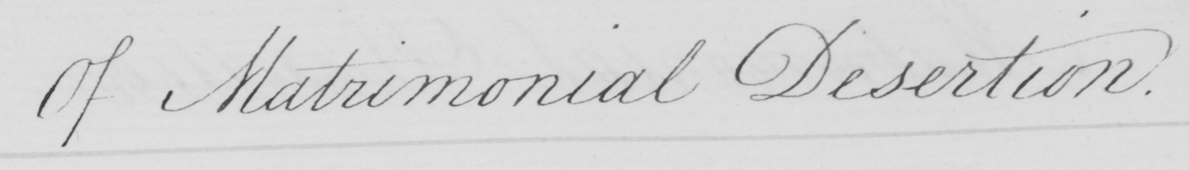What is written in this line of handwriting? Of Matrimonial Desertion. 